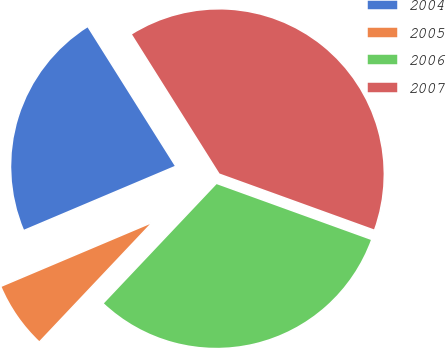<chart> <loc_0><loc_0><loc_500><loc_500><pie_chart><fcel>2004<fcel>2005<fcel>2006<fcel>2007<nl><fcel>22.43%<fcel>6.58%<fcel>31.53%<fcel>39.46%<nl></chart> 